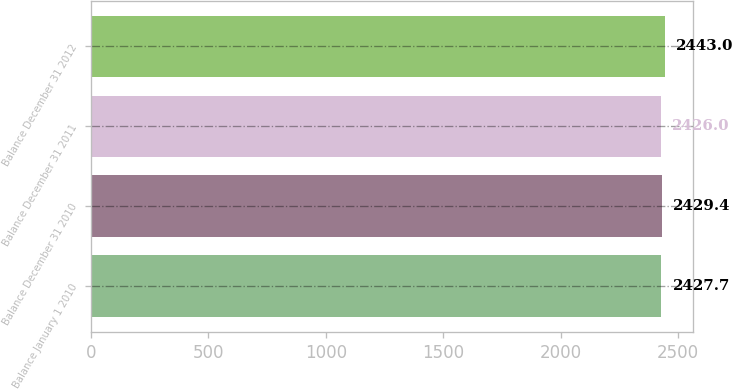<chart> <loc_0><loc_0><loc_500><loc_500><bar_chart><fcel>Balance January 1 2010<fcel>Balance December 31 2010<fcel>Balance December 31 2011<fcel>Balance December 31 2012<nl><fcel>2427.7<fcel>2429.4<fcel>2426<fcel>2443<nl></chart> 